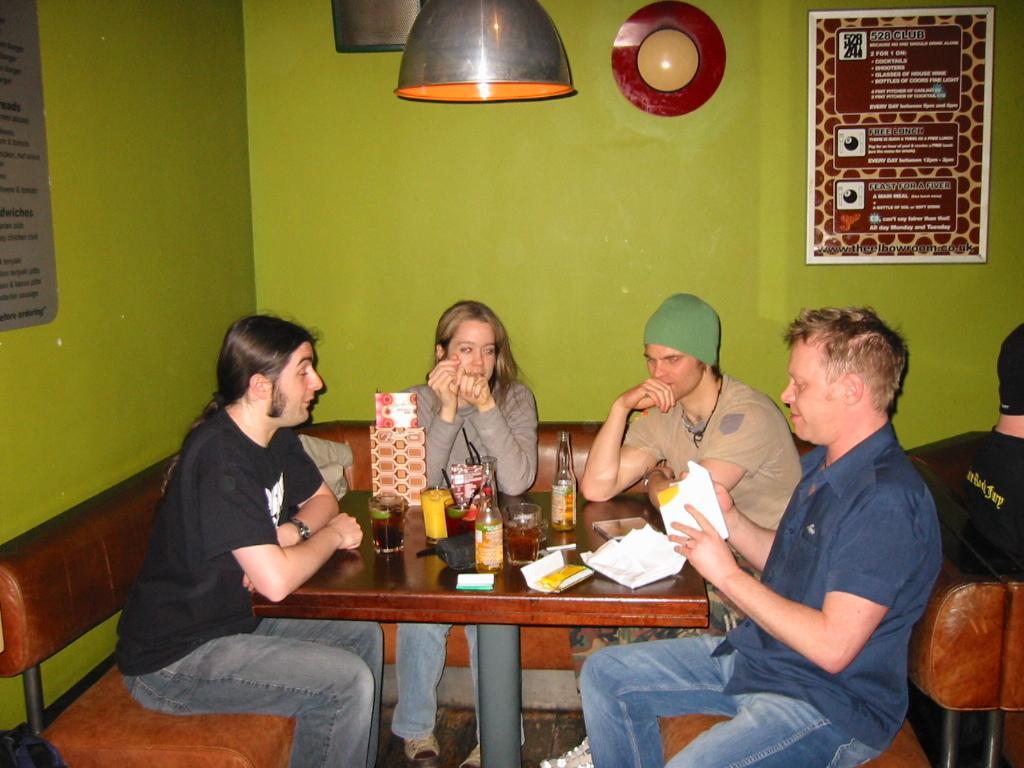Please provide a concise description of this image. In this picture we can see four persons are sitting on the sofa. This is table. On the table there are glasses, and bottles. On the background there is a wall and this is light. Here we can see a frame. 